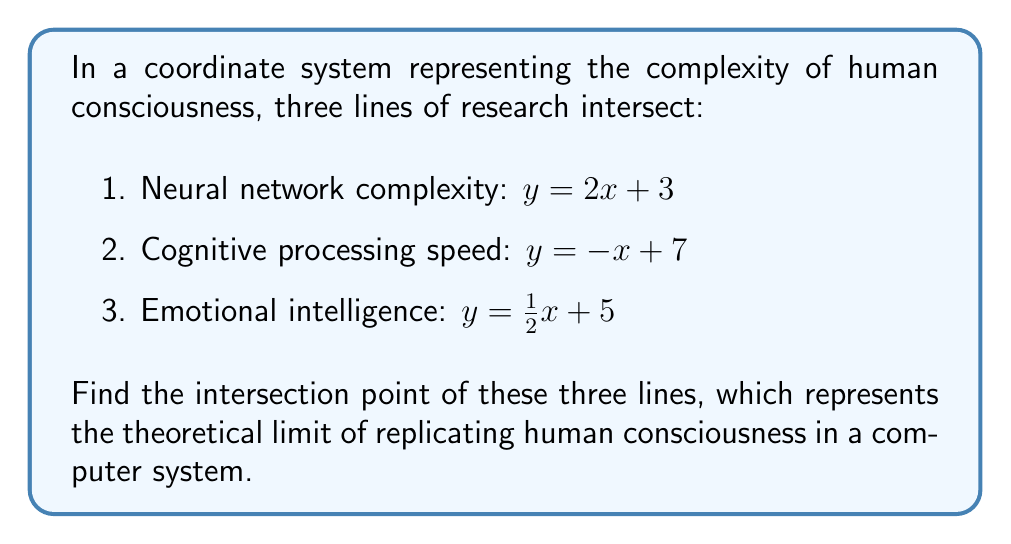Teach me how to tackle this problem. To find the intersection point of these three lines, we need to solve the system of equations:

$$
\begin{cases}
y = 2x + 3 \\
y = -x + 7 \\
y = \frac{1}{2}x + 5
\end{cases}
$$

Step 1: Equate the first two equations:
$2x + 3 = -x + 7$
$3x = 4$
$x = \frac{4}{3}$

Step 2: Substitute $x = \frac{4}{3}$ into the first equation:
$y = 2(\frac{4}{3}) + 3 = \frac{8}{3} + 3 = \frac{17}{3}$

Step 3: Verify that this point satisfies the third equation:
$\frac{17}{3} = \frac{1}{2}(\frac{4}{3}) + 5$
$\frac{17}{3} = \frac{2}{3} + 5 = \frac{17}{3}$

Therefore, the point $(\frac{4}{3}, \frac{17}{3})$ satisfies all three equations.

[asy]
import geometry;

size(200);
xaxis("x", -1, 6);
yaxis("y", -1, 8);

draw((0,3)--(3,9), blue);
draw((0,7)--(7,0), red);
draw((0,5)--(6,8), green);

dot((4/3, 17/3), black);
label("(4/3, 17/3)", (4/3, 17/3), NE);
[/asy]
Answer: $(\frac{4}{3}, \frac{17}{3})$ 